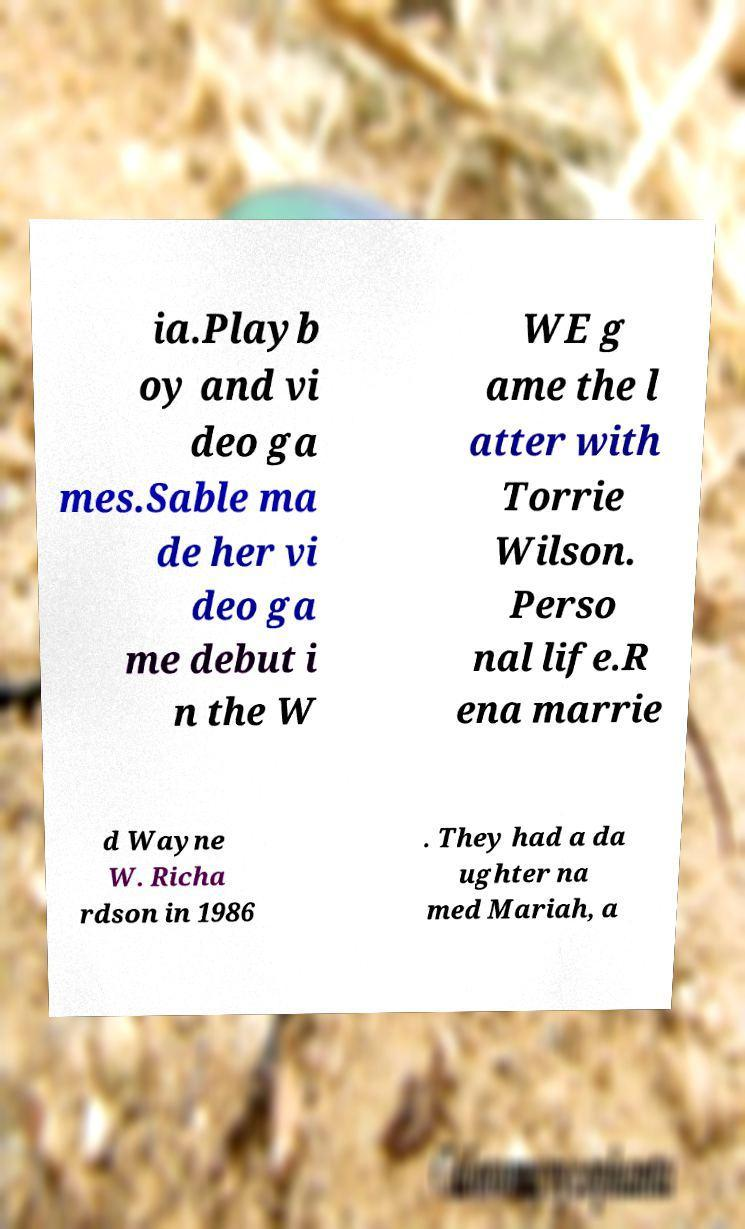Could you assist in decoding the text presented in this image and type it out clearly? ia.Playb oy and vi deo ga mes.Sable ma de her vi deo ga me debut i n the W WE g ame the l atter with Torrie Wilson. Perso nal life.R ena marrie d Wayne W. Richa rdson in 1986 . They had a da ughter na med Mariah, a 